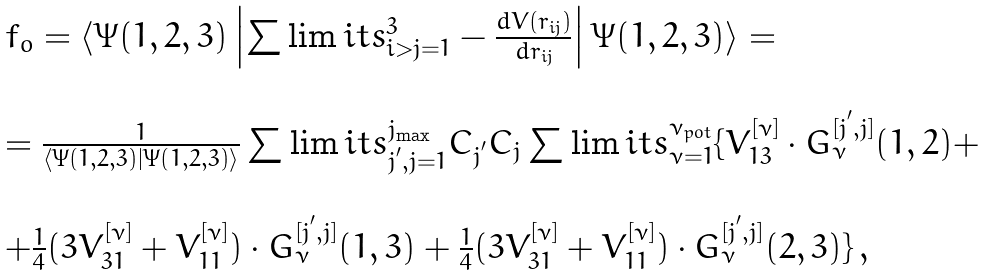Convert formula to latex. <formula><loc_0><loc_0><loc_500><loc_500>\begin{array} [ t ] { l c r } f _ { o } = \langle \Psi ( 1 , 2 , 3 ) \left | \sum \lim i t s _ { i > j = 1 } ^ { 3 } - \frac { d V ( r _ { i j } ) } { d r _ { i j } } \right | \Psi ( 1 , 2 , 3 ) \rangle = \\ \\ = \frac { 1 } { \langle \Psi ( 1 , 2 , 3 ) | \Psi ( 1 , 2 , 3 ) \rangle } \sum \lim i t s _ { j ^ { ^ { \prime } } , j = 1 } ^ { j _ { \max } } C _ { j ^ { ^ { \prime } } } C _ { j } \sum \lim i t s _ { \nu = 1 } ^ { \nu _ { p o t } } \{ V _ { 1 3 } ^ { [ \nu ] } \cdot G _ { \nu } ^ { [ j ^ { ^ { \prime } } , j ] } ( 1 , 2 ) + \\ \\ + \frac { 1 } { 4 } ( 3 V _ { 3 1 } ^ { [ \nu ] } + V _ { 1 1 } ^ { [ \nu ] } ) \cdot G _ { \nu } ^ { [ j ^ { ^ { \prime } } , j ] } ( 1 , 3 ) + \frac { 1 } { 4 } ( 3 V _ { 3 1 } ^ { [ \nu ] } + V _ { 1 1 } ^ { [ \nu ] } ) \cdot G _ { \nu } ^ { [ j ^ { ^ { \prime } } , j ] } ( 2 , 3 ) \} \, , \end{array}</formula> 